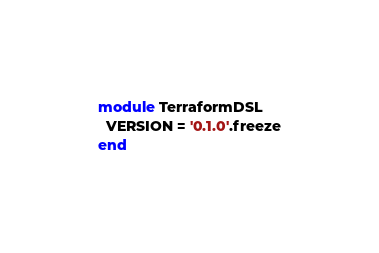<code> <loc_0><loc_0><loc_500><loc_500><_Ruby_>module TerraformDSL
  VERSION = '0.1.0'.freeze
end
</code> 